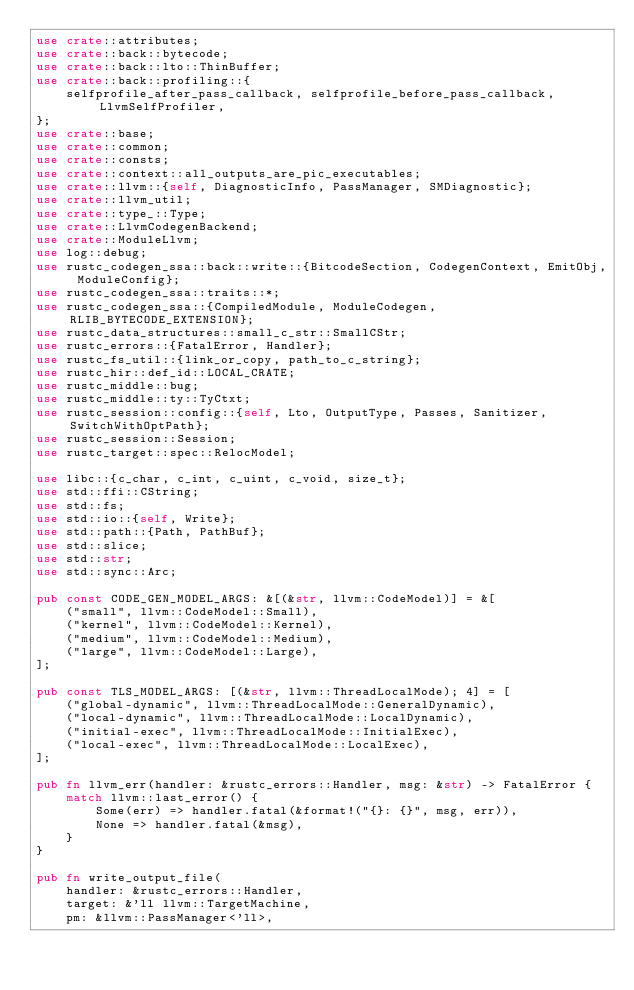Convert code to text. <code><loc_0><loc_0><loc_500><loc_500><_Rust_>use crate::attributes;
use crate::back::bytecode;
use crate::back::lto::ThinBuffer;
use crate::back::profiling::{
    selfprofile_after_pass_callback, selfprofile_before_pass_callback, LlvmSelfProfiler,
};
use crate::base;
use crate::common;
use crate::consts;
use crate::context::all_outputs_are_pic_executables;
use crate::llvm::{self, DiagnosticInfo, PassManager, SMDiagnostic};
use crate::llvm_util;
use crate::type_::Type;
use crate::LlvmCodegenBackend;
use crate::ModuleLlvm;
use log::debug;
use rustc_codegen_ssa::back::write::{BitcodeSection, CodegenContext, EmitObj, ModuleConfig};
use rustc_codegen_ssa::traits::*;
use rustc_codegen_ssa::{CompiledModule, ModuleCodegen, RLIB_BYTECODE_EXTENSION};
use rustc_data_structures::small_c_str::SmallCStr;
use rustc_errors::{FatalError, Handler};
use rustc_fs_util::{link_or_copy, path_to_c_string};
use rustc_hir::def_id::LOCAL_CRATE;
use rustc_middle::bug;
use rustc_middle::ty::TyCtxt;
use rustc_session::config::{self, Lto, OutputType, Passes, Sanitizer, SwitchWithOptPath};
use rustc_session::Session;
use rustc_target::spec::RelocModel;

use libc::{c_char, c_int, c_uint, c_void, size_t};
use std::ffi::CString;
use std::fs;
use std::io::{self, Write};
use std::path::{Path, PathBuf};
use std::slice;
use std::str;
use std::sync::Arc;

pub const CODE_GEN_MODEL_ARGS: &[(&str, llvm::CodeModel)] = &[
    ("small", llvm::CodeModel::Small),
    ("kernel", llvm::CodeModel::Kernel),
    ("medium", llvm::CodeModel::Medium),
    ("large", llvm::CodeModel::Large),
];

pub const TLS_MODEL_ARGS: [(&str, llvm::ThreadLocalMode); 4] = [
    ("global-dynamic", llvm::ThreadLocalMode::GeneralDynamic),
    ("local-dynamic", llvm::ThreadLocalMode::LocalDynamic),
    ("initial-exec", llvm::ThreadLocalMode::InitialExec),
    ("local-exec", llvm::ThreadLocalMode::LocalExec),
];

pub fn llvm_err(handler: &rustc_errors::Handler, msg: &str) -> FatalError {
    match llvm::last_error() {
        Some(err) => handler.fatal(&format!("{}: {}", msg, err)),
        None => handler.fatal(&msg),
    }
}

pub fn write_output_file(
    handler: &rustc_errors::Handler,
    target: &'ll llvm::TargetMachine,
    pm: &llvm::PassManager<'ll>,</code> 